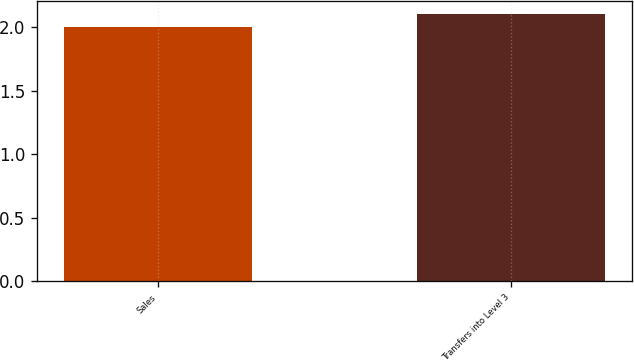<chart> <loc_0><loc_0><loc_500><loc_500><bar_chart><fcel>Sales<fcel>Transfers into Level 3<nl><fcel>2<fcel>2.1<nl></chart> 